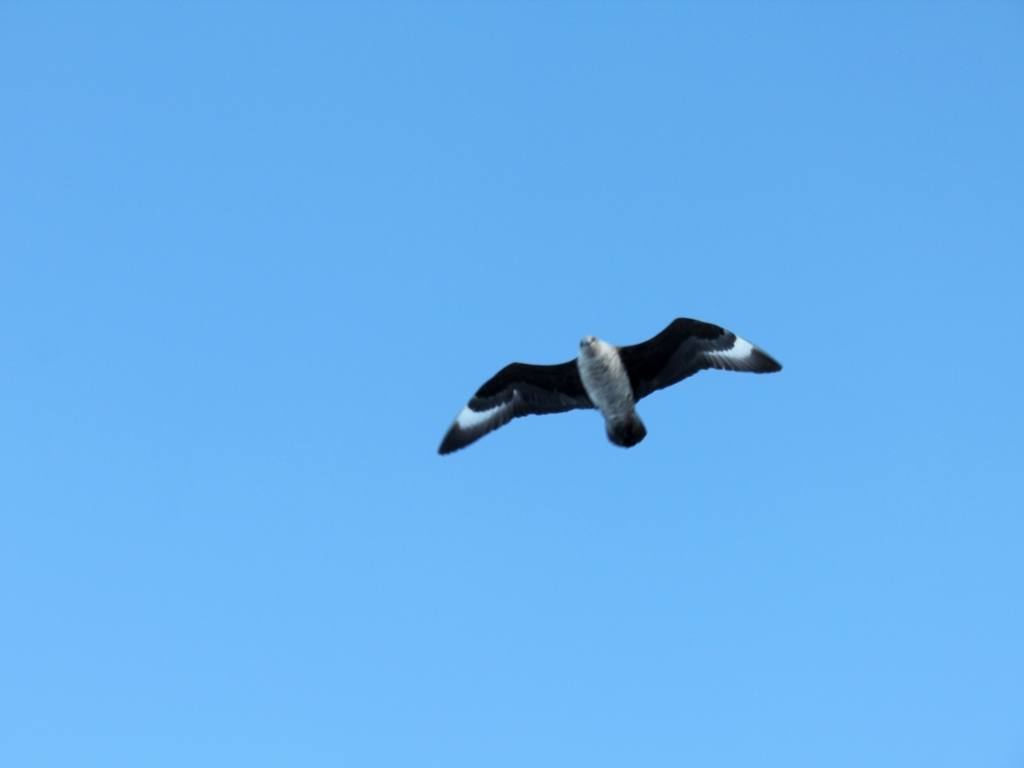What kind of bird is shown in this image? The bird in the image is difficult to identify conclusively due to the image's angle and the bird's position in flight. However, it appears to be a seabird, potentially an albatross or a gull, judging by the long wingspan and the color pattern on the wings. What time of day does this photo seem to be taken? Based on the bright blue sky and the position of the bird's shadow, it seems like the photograph was taken during the day when the sun was relatively high in the sky. 